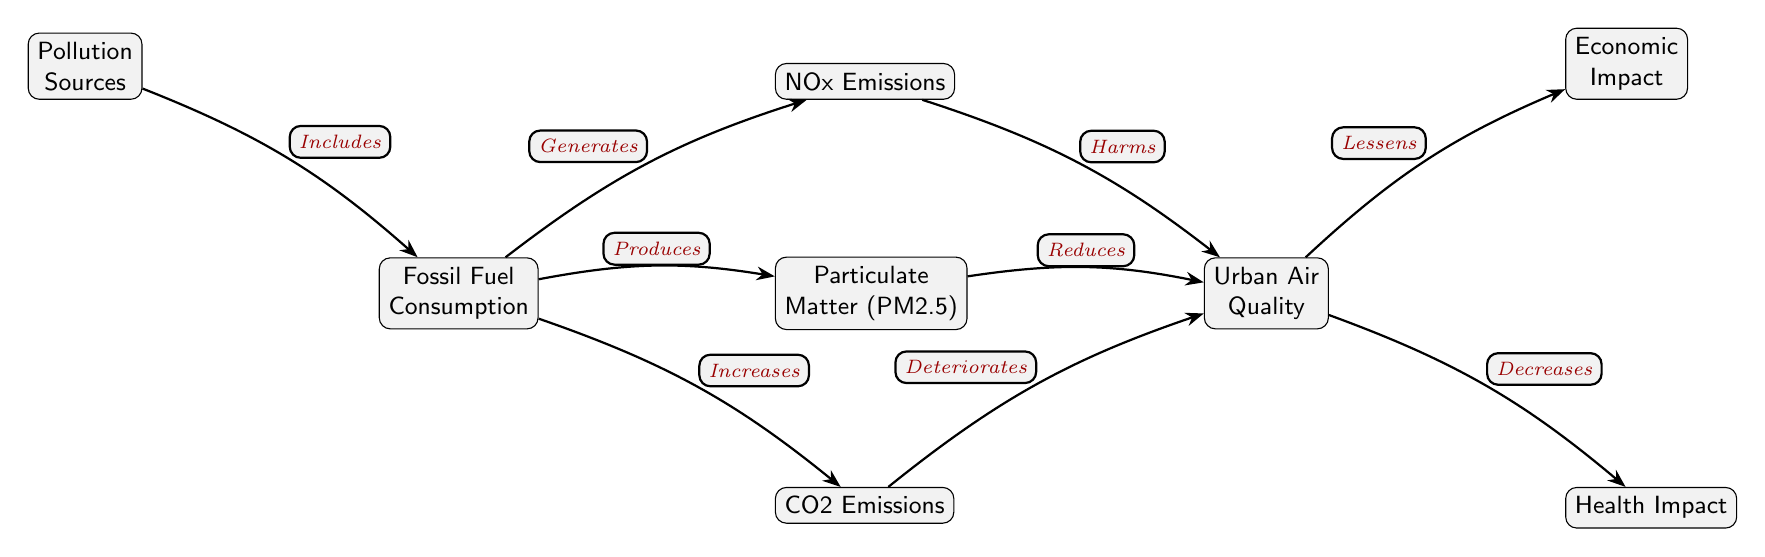What is the main input to the diagram? The main input represented in the diagram is "Fossil Fuel Consumption," which is indicated as the starting node. It's where the influence on air quality begins.
Answer: Fossil Fuel Consumption How many pollution sources are indicated in the diagram? The diagram has one node that specifically refers to "Pollution Sources," which is connected to the main input.
Answer: One What does fossil fuel consumption generate? The diagram links "Fossil Fuel Consumption" to the node "NOx Emissions," indicating that it produces emissions associated with nitrogen oxides.
Answer: NOx Emissions How does CO2 emissions affect urban air quality? The diagram shows an arrow from "CO2 Emissions" to "Urban Air Quality," labeled "Deteriorates," meaning that increased CO2 reduces air quality.
Answer: Deteriorates What are the two impacts of urban air quality shown in the diagram? The diagram indicates two impacts stemming from "Urban Air Quality": "Health Impact" and "Economic Impact." Both of these are ramifications connected to the quality of air in urban areas.
Answer: Health Impact and Economic Impact Which pollutant directly harms urban air quality? The diagram specifies that "NOx Emissions" harms urban air quality, as indicated by the directed connection labeled "Harms."
Answer: NOx Emissions How many indicators are shown as consequences of fossil fuel consumption? There are three consequences indicated in the diagram stemming from "Fossil Fuel Consumption": "CO2 Emissions," "Particulate Matter (PM2.5)," and "NOx Emissions." This indicates the breadth of pollutants generated by fossil fuel usage.
Answer: Three If urban air quality decreases, what does that lead to? The diagram shows a direct connection from "Urban Air Quality" to "Health Impact," indicating that a decline in air quality is linked to adverse health effects.
Answer: Decreases How does particulate matter affect urban air quality? The diagram indicates that "Particulate Matter (PM2.5)" produces a reduction in "Urban Air Quality," which is represented by the label "Reduces."
Answer: Reduces 